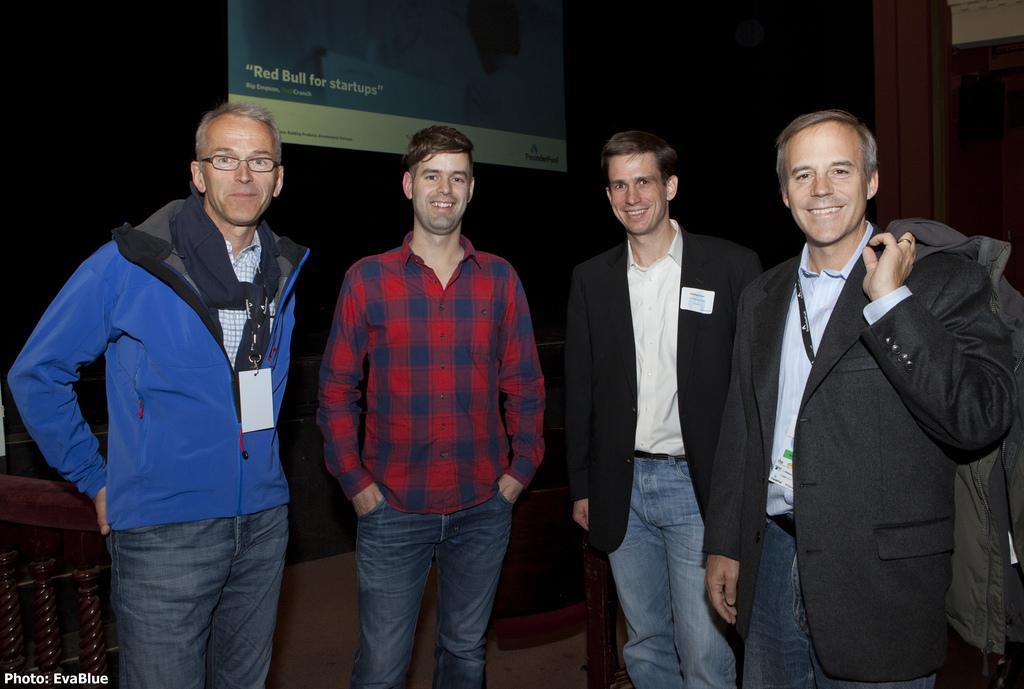Describe this image in one or two sentences. In the foreground of this image, there are four men standing and having smile on their faces. In the dark background, there is a screen and it seems like few chairs in the background. 